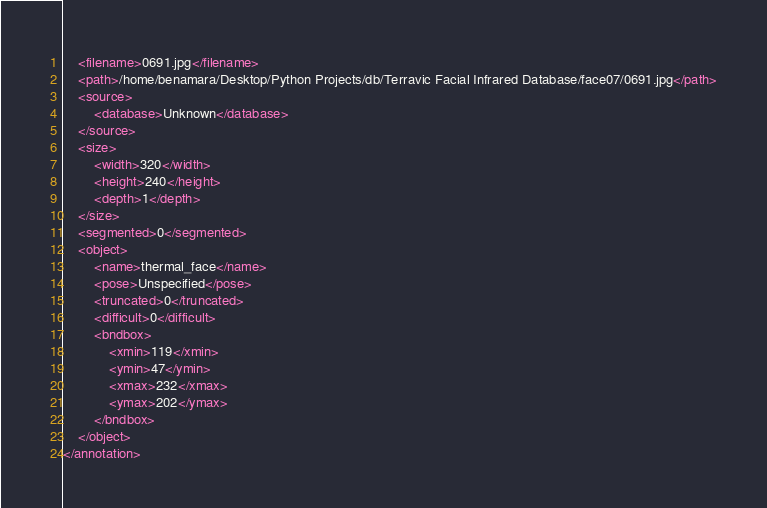<code> <loc_0><loc_0><loc_500><loc_500><_XML_>	<filename>0691.jpg</filename>
	<path>/home/benamara/Desktop/Python Projects/db/Terravic Facial Infrared Database/face07/0691.jpg</path>
	<source>
		<database>Unknown</database>
	</source>
	<size>
		<width>320</width>
		<height>240</height>
		<depth>1</depth>
	</size>
	<segmented>0</segmented>
	<object>
		<name>thermal_face</name>
		<pose>Unspecified</pose>
		<truncated>0</truncated>
		<difficult>0</difficult>
		<bndbox>
			<xmin>119</xmin>
			<ymin>47</ymin>
			<xmax>232</xmax>
			<ymax>202</ymax>
		</bndbox>
	</object>
</annotation>
</code> 